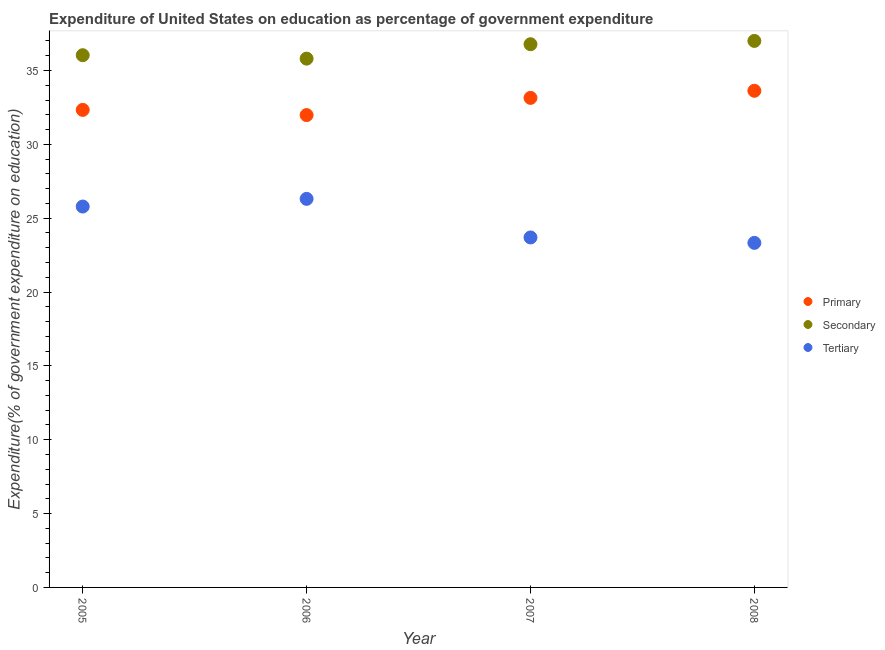What is the expenditure on tertiary education in 2006?
Ensure brevity in your answer.  26.31. Across all years, what is the maximum expenditure on primary education?
Offer a very short reply. 33.63. Across all years, what is the minimum expenditure on primary education?
Offer a very short reply. 31.98. In which year was the expenditure on primary education minimum?
Provide a short and direct response. 2006. What is the total expenditure on tertiary education in the graph?
Provide a succinct answer. 99.13. What is the difference between the expenditure on tertiary education in 2005 and that in 2006?
Ensure brevity in your answer.  -0.52. What is the difference between the expenditure on tertiary education in 2007 and the expenditure on secondary education in 2005?
Provide a succinct answer. -12.34. What is the average expenditure on secondary education per year?
Make the answer very short. 36.41. In the year 2008, what is the difference between the expenditure on tertiary education and expenditure on primary education?
Provide a short and direct response. -10.3. What is the ratio of the expenditure on tertiary education in 2006 to that in 2007?
Make the answer very short. 1.11. Is the expenditure on primary education in 2006 less than that in 2007?
Your answer should be very brief. Yes. Is the difference between the expenditure on tertiary education in 2005 and 2007 greater than the difference between the expenditure on primary education in 2005 and 2007?
Provide a succinct answer. Yes. What is the difference between the highest and the second highest expenditure on secondary education?
Provide a short and direct response. 0.22. What is the difference between the highest and the lowest expenditure on tertiary education?
Give a very brief answer. 2.98. In how many years, is the expenditure on tertiary education greater than the average expenditure on tertiary education taken over all years?
Ensure brevity in your answer.  2. Is the sum of the expenditure on secondary education in 2006 and 2007 greater than the maximum expenditure on primary education across all years?
Ensure brevity in your answer.  Yes. Is it the case that in every year, the sum of the expenditure on primary education and expenditure on secondary education is greater than the expenditure on tertiary education?
Your answer should be compact. Yes. Does the expenditure on primary education monotonically increase over the years?
Offer a terse response. No. Is the expenditure on primary education strictly less than the expenditure on tertiary education over the years?
Offer a very short reply. No. What is the difference between two consecutive major ticks on the Y-axis?
Offer a very short reply. 5. Does the graph contain any zero values?
Provide a succinct answer. No. Does the graph contain grids?
Make the answer very short. No. How many legend labels are there?
Provide a short and direct response. 3. What is the title of the graph?
Offer a very short reply. Expenditure of United States on education as percentage of government expenditure. What is the label or title of the X-axis?
Ensure brevity in your answer.  Year. What is the label or title of the Y-axis?
Your answer should be compact. Expenditure(% of government expenditure on education). What is the Expenditure(% of government expenditure on education) of Primary in 2005?
Your response must be concise. 32.33. What is the Expenditure(% of government expenditure on education) in Secondary in 2005?
Keep it short and to the point. 36.04. What is the Expenditure(% of government expenditure on education) in Tertiary in 2005?
Your response must be concise. 25.79. What is the Expenditure(% of government expenditure on education) of Primary in 2006?
Give a very brief answer. 31.98. What is the Expenditure(% of government expenditure on education) of Secondary in 2006?
Offer a terse response. 35.81. What is the Expenditure(% of government expenditure on education) in Tertiary in 2006?
Provide a succinct answer. 26.31. What is the Expenditure(% of government expenditure on education) in Primary in 2007?
Your answer should be compact. 33.15. What is the Expenditure(% of government expenditure on education) of Secondary in 2007?
Give a very brief answer. 36.78. What is the Expenditure(% of government expenditure on education) of Tertiary in 2007?
Offer a very short reply. 23.7. What is the Expenditure(% of government expenditure on education) in Primary in 2008?
Your response must be concise. 33.63. What is the Expenditure(% of government expenditure on education) in Secondary in 2008?
Provide a short and direct response. 37. What is the Expenditure(% of government expenditure on education) in Tertiary in 2008?
Provide a short and direct response. 23.33. Across all years, what is the maximum Expenditure(% of government expenditure on education) in Primary?
Give a very brief answer. 33.63. Across all years, what is the maximum Expenditure(% of government expenditure on education) in Secondary?
Keep it short and to the point. 37. Across all years, what is the maximum Expenditure(% of government expenditure on education) of Tertiary?
Provide a short and direct response. 26.31. Across all years, what is the minimum Expenditure(% of government expenditure on education) of Primary?
Make the answer very short. 31.98. Across all years, what is the minimum Expenditure(% of government expenditure on education) of Secondary?
Give a very brief answer. 35.81. Across all years, what is the minimum Expenditure(% of government expenditure on education) in Tertiary?
Keep it short and to the point. 23.33. What is the total Expenditure(% of government expenditure on education) in Primary in the graph?
Offer a terse response. 131.09. What is the total Expenditure(% of government expenditure on education) of Secondary in the graph?
Give a very brief answer. 145.63. What is the total Expenditure(% of government expenditure on education) in Tertiary in the graph?
Offer a very short reply. 99.13. What is the difference between the Expenditure(% of government expenditure on education) of Primary in 2005 and that in 2006?
Offer a very short reply. 0.35. What is the difference between the Expenditure(% of government expenditure on education) in Secondary in 2005 and that in 2006?
Give a very brief answer. 0.23. What is the difference between the Expenditure(% of government expenditure on education) of Tertiary in 2005 and that in 2006?
Provide a succinct answer. -0.52. What is the difference between the Expenditure(% of government expenditure on education) of Primary in 2005 and that in 2007?
Ensure brevity in your answer.  -0.81. What is the difference between the Expenditure(% of government expenditure on education) of Secondary in 2005 and that in 2007?
Your answer should be compact. -0.74. What is the difference between the Expenditure(% of government expenditure on education) in Tertiary in 2005 and that in 2007?
Your answer should be compact. 2.09. What is the difference between the Expenditure(% of government expenditure on education) of Primary in 2005 and that in 2008?
Offer a very short reply. -1.29. What is the difference between the Expenditure(% of government expenditure on education) in Secondary in 2005 and that in 2008?
Make the answer very short. -0.97. What is the difference between the Expenditure(% of government expenditure on education) in Tertiary in 2005 and that in 2008?
Keep it short and to the point. 2.46. What is the difference between the Expenditure(% of government expenditure on education) in Primary in 2006 and that in 2007?
Your answer should be compact. -1.16. What is the difference between the Expenditure(% of government expenditure on education) of Secondary in 2006 and that in 2007?
Your response must be concise. -0.97. What is the difference between the Expenditure(% of government expenditure on education) in Tertiary in 2006 and that in 2007?
Your response must be concise. 2.61. What is the difference between the Expenditure(% of government expenditure on education) of Primary in 2006 and that in 2008?
Make the answer very short. -1.65. What is the difference between the Expenditure(% of government expenditure on education) in Secondary in 2006 and that in 2008?
Your answer should be compact. -1.2. What is the difference between the Expenditure(% of government expenditure on education) in Tertiary in 2006 and that in 2008?
Keep it short and to the point. 2.98. What is the difference between the Expenditure(% of government expenditure on education) in Primary in 2007 and that in 2008?
Your answer should be compact. -0.48. What is the difference between the Expenditure(% of government expenditure on education) in Secondary in 2007 and that in 2008?
Provide a succinct answer. -0.22. What is the difference between the Expenditure(% of government expenditure on education) in Tertiary in 2007 and that in 2008?
Provide a short and direct response. 0.37. What is the difference between the Expenditure(% of government expenditure on education) in Primary in 2005 and the Expenditure(% of government expenditure on education) in Secondary in 2006?
Provide a short and direct response. -3.47. What is the difference between the Expenditure(% of government expenditure on education) in Primary in 2005 and the Expenditure(% of government expenditure on education) in Tertiary in 2006?
Provide a succinct answer. 6.02. What is the difference between the Expenditure(% of government expenditure on education) in Secondary in 2005 and the Expenditure(% of government expenditure on education) in Tertiary in 2006?
Your response must be concise. 9.73. What is the difference between the Expenditure(% of government expenditure on education) in Primary in 2005 and the Expenditure(% of government expenditure on education) in Secondary in 2007?
Offer a very short reply. -4.45. What is the difference between the Expenditure(% of government expenditure on education) in Primary in 2005 and the Expenditure(% of government expenditure on education) in Tertiary in 2007?
Make the answer very short. 8.64. What is the difference between the Expenditure(% of government expenditure on education) in Secondary in 2005 and the Expenditure(% of government expenditure on education) in Tertiary in 2007?
Keep it short and to the point. 12.34. What is the difference between the Expenditure(% of government expenditure on education) of Primary in 2005 and the Expenditure(% of government expenditure on education) of Secondary in 2008?
Offer a very short reply. -4.67. What is the difference between the Expenditure(% of government expenditure on education) in Primary in 2005 and the Expenditure(% of government expenditure on education) in Tertiary in 2008?
Your response must be concise. 9. What is the difference between the Expenditure(% of government expenditure on education) of Secondary in 2005 and the Expenditure(% of government expenditure on education) of Tertiary in 2008?
Keep it short and to the point. 12.71. What is the difference between the Expenditure(% of government expenditure on education) in Primary in 2006 and the Expenditure(% of government expenditure on education) in Secondary in 2007?
Give a very brief answer. -4.8. What is the difference between the Expenditure(% of government expenditure on education) of Primary in 2006 and the Expenditure(% of government expenditure on education) of Tertiary in 2007?
Keep it short and to the point. 8.29. What is the difference between the Expenditure(% of government expenditure on education) of Secondary in 2006 and the Expenditure(% of government expenditure on education) of Tertiary in 2007?
Make the answer very short. 12.11. What is the difference between the Expenditure(% of government expenditure on education) in Primary in 2006 and the Expenditure(% of government expenditure on education) in Secondary in 2008?
Offer a terse response. -5.02. What is the difference between the Expenditure(% of government expenditure on education) in Primary in 2006 and the Expenditure(% of government expenditure on education) in Tertiary in 2008?
Offer a terse response. 8.65. What is the difference between the Expenditure(% of government expenditure on education) in Secondary in 2006 and the Expenditure(% of government expenditure on education) in Tertiary in 2008?
Your response must be concise. 12.48. What is the difference between the Expenditure(% of government expenditure on education) in Primary in 2007 and the Expenditure(% of government expenditure on education) in Secondary in 2008?
Give a very brief answer. -3.86. What is the difference between the Expenditure(% of government expenditure on education) in Primary in 2007 and the Expenditure(% of government expenditure on education) in Tertiary in 2008?
Your answer should be very brief. 9.82. What is the difference between the Expenditure(% of government expenditure on education) in Secondary in 2007 and the Expenditure(% of government expenditure on education) in Tertiary in 2008?
Ensure brevity in your answer.  13.45. What is the average Expenditure(% of government expenditure on education) of Primary per year?
Give a very brief answer. 32.77. What is the average Expenditure(% of government expenditure on education) in Secondary per year?
Your response must be concise. 36.41. What is the average Expenditure(% of government expenditure on education) in Tertiary per year?
Keep it short and to the point. 24.78. In the year 2005, what is the difference between the Expenditure(% of government expenditure on education) in Primary and Expenditure(% of government expenditure on education) in Secondary?
Keep it short and to the point. -3.7. In the year 2005, what is the difference between the Expenditure(% of government expenditure on education) of Primary and Expenditure(% of government expenditure on education) of Tertiary?
Offer a very short reply. 6.54. In the year 2005, what is the difference between the Expenditure(% of government expenditure on education) in Secondary and Expenditure(% of government expenditure on education) in Tertiary?
Provide a succinct answer. 10.25. In the year 2006, what is the difference between the Expenditure(% of government expenditure on education) of Primary and Expenditure(% of government expenditure on education) of Secondary?
Ensure brevity in your answer.  -3.82. In the year 2006, what is the difference between the Expenditure(% of government expenditure on education) in Primary and Expenditure(% of government expenditure on education) in Tertiary?
Provide a short and direct response. 5.67. In the year 2006, what is the difference between the Expenditure(% of government expenditure on education) in Secondary and Expenditure(% of government expenditure on education) in Tertiary?
Make the answer very short. 9.5. In the year 2007, what is the difference between the Expenditure(% of government expenditure on education) in Primary and Expenditure(% of government expenditure on education) in Secondary?
Offer a terse response. -3.63. In the year 2007, what is the difference between the Expenditure(% of government expenditure on education) in Primary and Expenditure(% of government expenditure on education) in Tertiary?
Provide a short and direct response. 9.45. In the year 2007, what is the difference between the Expenditure(% of government expenditure on education) of Secondary and Expenditure(% of government expenditure on education) of Tertiary?
Offer a very short reply. 13.08. In the year 2008, what is the difference between the Expenditure(% of government expenditure on education) of Primary and Expenditure(% of government expenditure on education) of Secondary?
Make the answer very short. -3.38. In the year 2008, what is the difference between the Expenditure(% of government expenditure on education) of Primary and Expenditure(% of government expenditure on education) of Tertiary?
Ensure brevity in your answer.  10.3. In the year 2008, what is the difference between the Expenditure(% of government expenditure on education) in Secondary and Expenditure(% of government expenditure on education) in Tertiary?
Your answer should be compact. 13.67. What is the ratio of the Expenditure(% of government expenditure on education) in Primary in 2005 to that in 2006?
Your response must be concise. 1.01. What is the ratio of the Expenditure(% of government expenditure on education) in Secondary in 2005 to that in 2006?
Provide a short and direct response. 1.01. What is the ratio of the Expenditure(% of government expenditure on education) of Tertiary in 2005 to that in 2006?
Offer a terse response. 0.98. What is the ratio of the Expenditure(% of government expenditure on education) of Primary in 2005 to that in 2007?
Your answer should be compact. 0.98. What is the ratio of the Expenditure(% of government expenditure on education) of Secondary in 2005 to that in 2007?
Your answer should be compact. 0.98. What is the ratio of the Expenditure(% of government expenditure on education) in Tertiary in 2005 to that in 2007?
Keep it short and to the point. 1.09. What is the ratio of the Expenditure(% of government expenditure on education) of Primary in 2005 to that in 2008?
Provide a short and direct response. 0.96. What is the ratio of the Expenditure(% of government expenditure on education) in Secondary in 2005 to that in 2008?
Offer a very short reply. 0.97. What is the ratio of the Expenditure(% of government expenditure on education) in Tertiary in 2005 to that in 2008?
Your answer should be very brief. 1.11. What is the ratio of the Expenditure(% of government expenditure on education) of Primary in 2006 to that in 2007?
Offer a terse response. 0.96. What is the ratio of the Expenditure(% of government expenditure on education) in Secondary in 2006 to that in 2007?
Keep it short and to the point. 0.97. What is the ratio of the Expenditure(% of government expenditure on education) of Tertiary in 2006 to that in 2007?
Your answer should be very brief. 1.11. What is the ratio of the Expenditure(% of government expenditure on education) of Primary in 2006 to that in 2008?
Ensure brevity in your answer.  0.95. What is the ratio of the Expenditure(% of government expenditure on education) in Secondary in 2006 to that in 2008?
Your answer should be very brief. 0.97. What is the ratio of the Expenditure(% of government expenditure on education) of Tertiary in 2006 to that in 2008?
Offer a very short reply. 1.13. What is the ratio of the Expenditure(% of government expenditure on education) in Primary in 2007 to that in 2008?
Provide a succinct answer. 0.99. What is the ratio of the Expenditure(% of government expenditure on education) in Tertiary in 2007 to that in 2008?
Your answer should be very brief. 1.02. What is the difference between the highest and the second highest Expenditure(% of government expenditure on education) of Primary?
Offer a very short reply. 0.48. What is the difference between the highest and the second highest Expenditure(% of government expenditure on education) of Secondary?
Make the answer very short. 0.22. What is the difference between the highest and the second highest Expenditure(% of government expenditure on education) in Tertiary?
Give a very brief answer. 0.52. What is the difference between the highest and the lowest Expenditure(% of government expenditure on education) of Primary?
Keep it short and to the point. 1.65. What is the difference between the highest and the lowest Expenditure(% of government expenditure on education) in Secondary?
Ensure brevity in your answer.  1.2. What is the difference between the highest and the lowest Expenditure(% of government expenditure on education) in Tertiary?
Your answer should be compact. 2.98. 